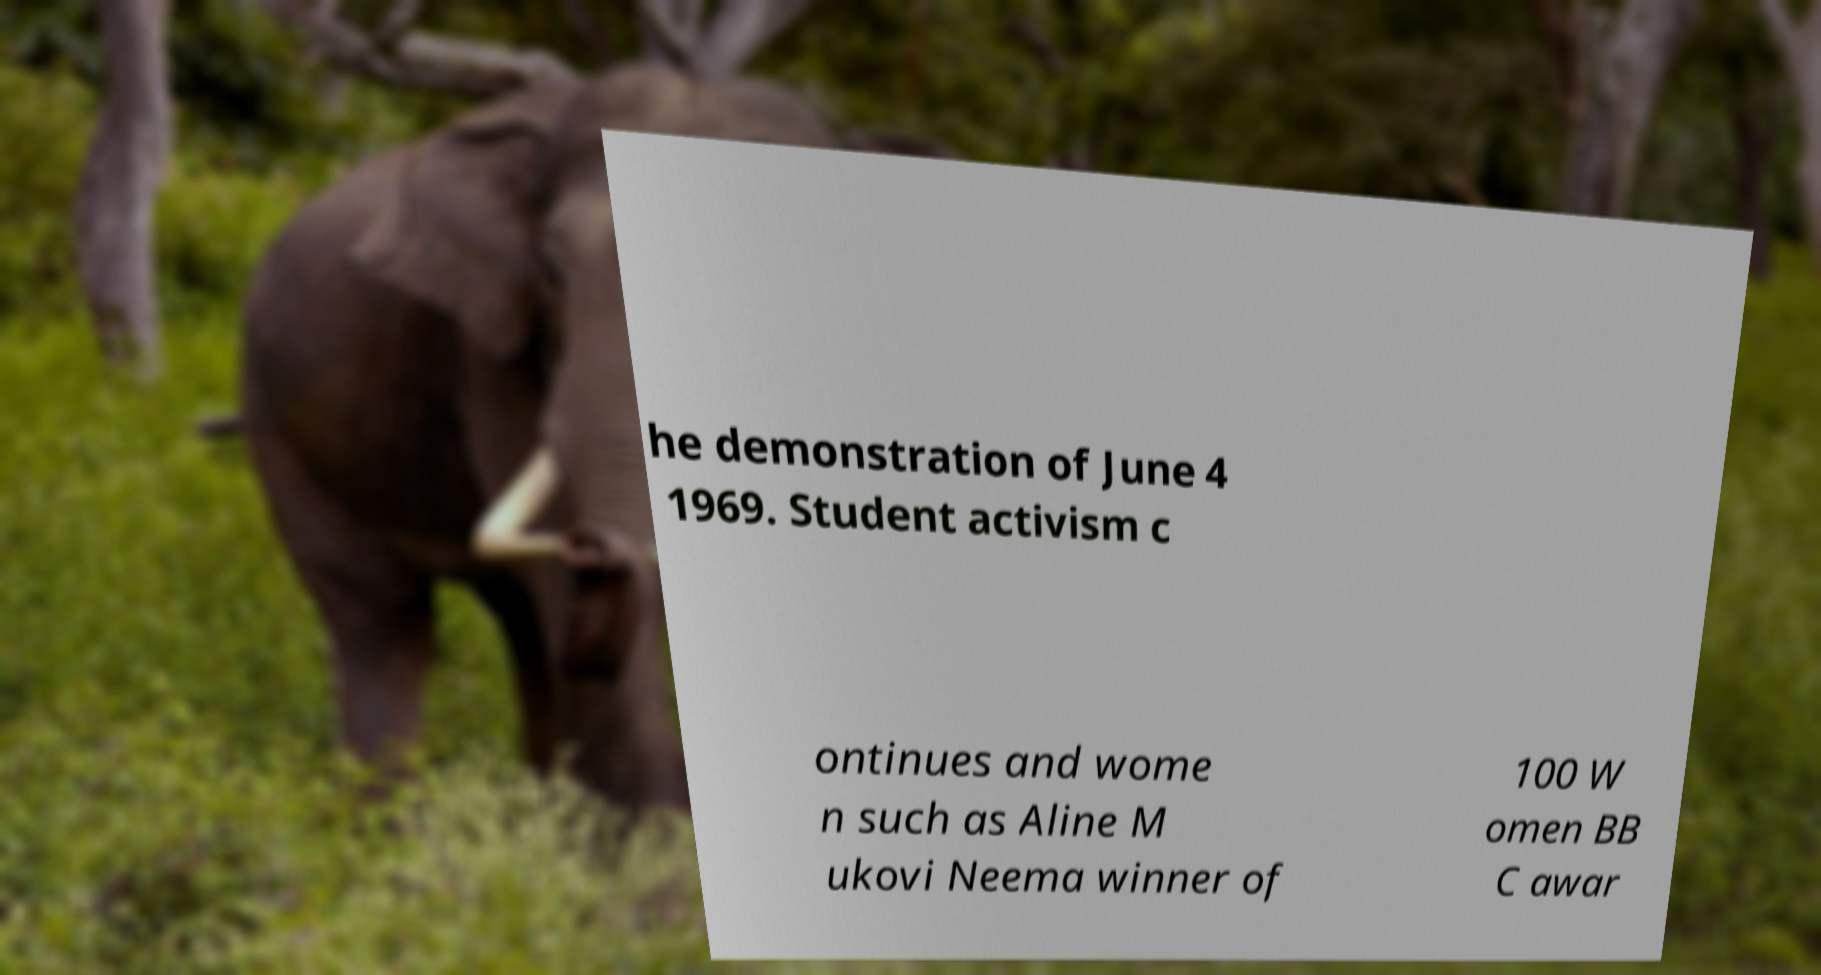Could you extract and type out the text from this image? he demonstration of June 4 1969. Student activism c ontinues and wome n such as Aline M ukovi Neema winner of 100 W omen BB C awar 